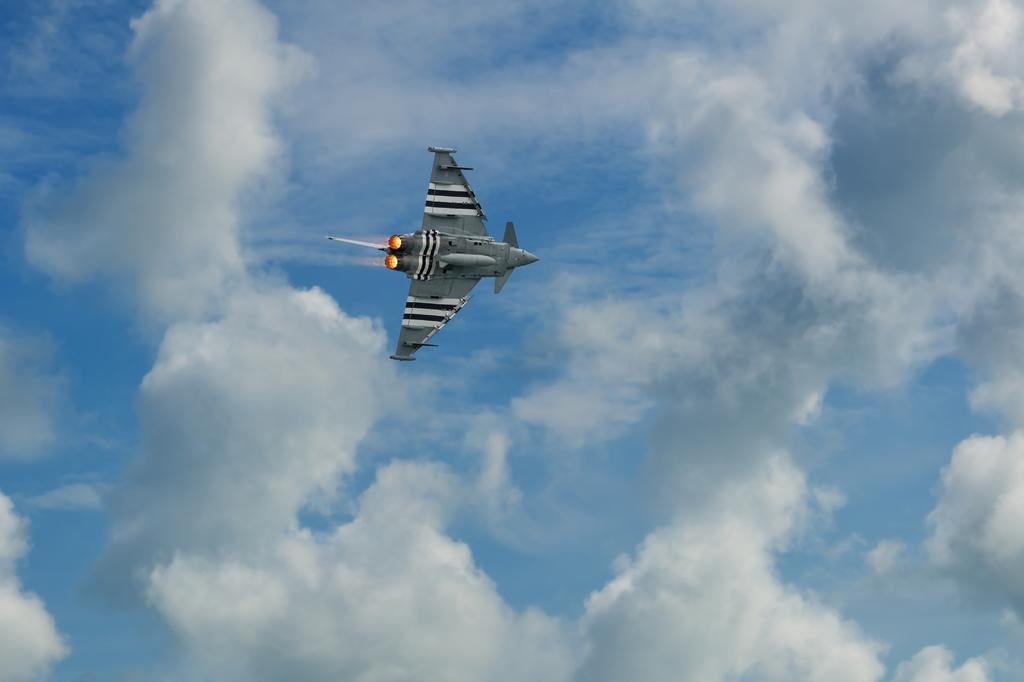What is the main subject of the image? The main subject of the image is an airplane. Can you describe the location of the airplane in the image? The airplane is in the air in the image. What can be seen in the background of the image? There is sky visible in the background of the image. What is the condition of the sky in the image? Clouds are present in the sky in the image. What type of river can be seen flowing beneath the airplane in the image? There is no river present in the image; it features an airplane in the sky. What is the plot of the story being told in the image? The image does not tell a story or have a plot; it is a photograph of an airplane in the sky. 